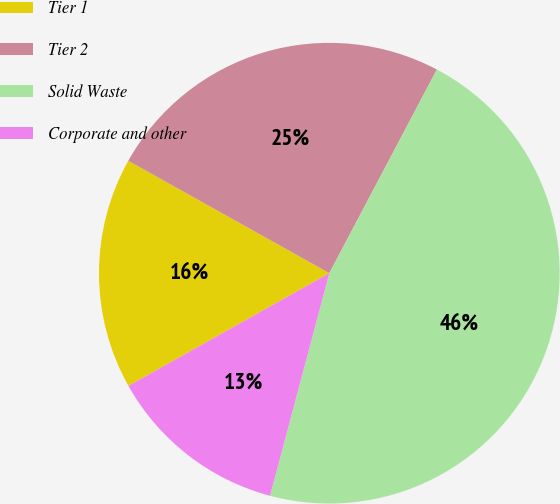Convert chart. <chart><loc_0><loc_0><loc_500><loc_500><pie_chart><fcel>Tier 1<fcel>Tier 2<fcel>Solid Waste<fcel>Corporate and other<nl><fcel>16.25%<fcel>24.62%<fcel>46.41%<fcel>12.72%<nl></chart> 